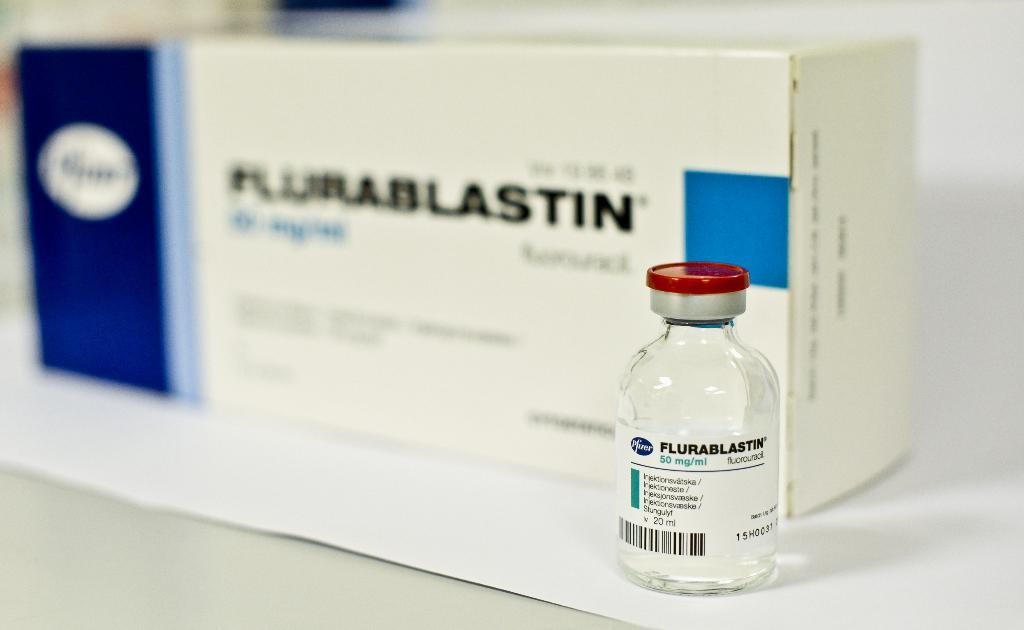What is the main object in the image? There is a white color box in the image. What other object can be seen in the image? There is a bottle in the image. What is the color of the bottle? The bottle is white in color. How many children are playing with the bottle in the image? There are no children present in the image, and the bottle is not being played with. 